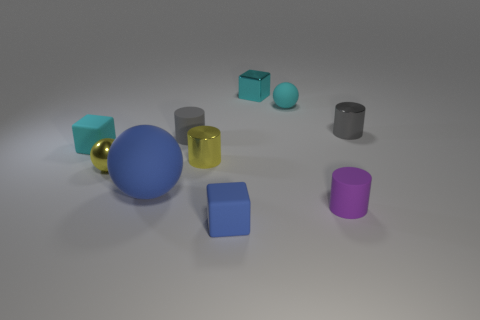There is a rubber cube that is to the left of the small yellow shiny sphere; what number of purple cylinders are behind it?
Your answer should be very brief. 0. Is the number of purple cylinders in front of the yellow sphere less than the number of yellow shiny objects?
Ensure brevity in your answer.  Yes. There is a matte cylinder that is behind the big thing in front of the small gray rubber thing; are there any blue rubber balls in front of it?
Offer a very short reply. Yes. Does the tiny blue cube have the same material as the small ball behind the tiny cyan rubber cube?
Provide a succinct answer. Yes. What is the color of the rubber ball on the right side of the blue object to the left of the small blue matte object?
Give a very brief answer. Cyan. Is there a tiny rubber sphere of the same color as the metallic block?
Provide a short and direct response. Yes. There is a shiny object behind the small ball that is on the right side of the yellow sphere that is behind the small blue matte thing; how big is it?
Your answer should be compact. Small. There is a purple object; is it the same shape as the tiny gray object that is in front of the gray metallic cylinder?
Offer a very short reply. Yes. How many other objects are the same size as the metal sphere?
Provide a short and direct response. 8. There is a cyan thing that is to the left of the metallic ball; what is its size?
Your answer should be compact. Small. 